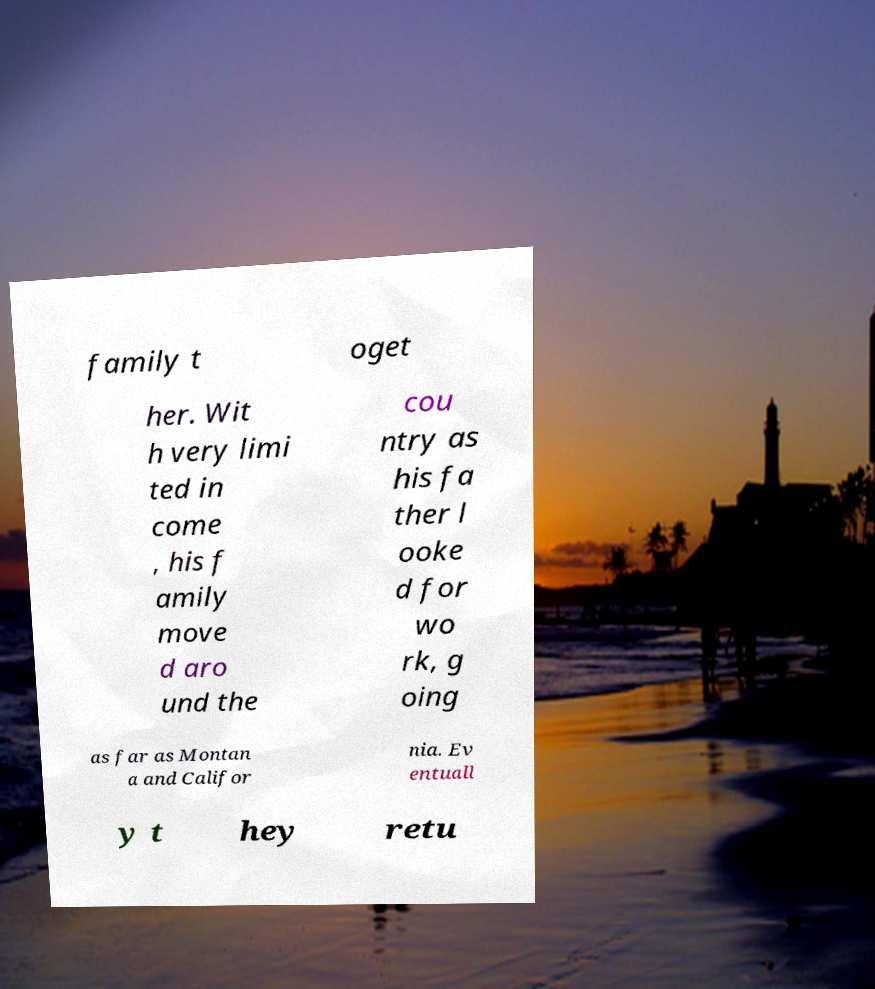Please read and relay the text visible in this image. What does it say? family t oget her. Wit h very limi ted in come , his f amily move d aro und the cou ntry as his fa ther l ooke d for wo rk, g oing as far as Montan a and Califor nia. Ev entuall y t hey retu 